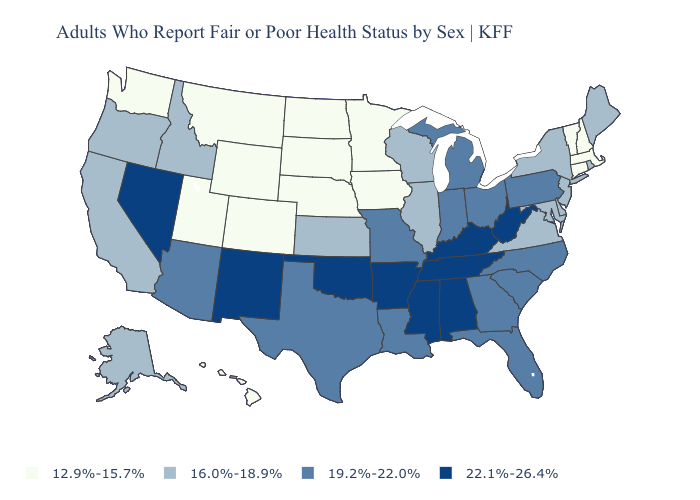Which states have the highest value in the USA?
Answer briefly. Alabama, Arkansas, Kentucky, Mississippi, Nevada, New Mexico, Oklahoma, Tennessee, West Virginia. What is the highest value in the USA?
Concise answer only. 22.1%-26.4%. What is the lowest value in states that border Idaho?
Answer briefly. 12.9%-15.7%. Among the states that border New Jersey , which have the lowest value?
Answer briefly. Delaware, New York. Name the states that have a value in the range 22.1%-26.4%?
Short answer required. Alabama, Arkansas, Kentucky, Mississippi, Nevada, New Mexico, Oklahoma, Tennessee, West Virginia. What is the value of Iowa?
Short answer required. 12.9%-15.7%. Which states hav the highest value in the Northeast?
Write a very short answer. Pennsylvania. Which states have the highest value in the USA?
Short answer required. Alabama, Arkansas, Kentucky, Mississippi, Nevada, New Mexico, Oklahoma, Tennessee, West Virginia. What is the lowest value in states that border Kansas?
Give a very brief answer. 12.9%-15.7%. Name the states that have a value in the range 22.1%-26.4%?
Concise answer only. Alabama, Arkansas, Kentucky, Mississippi, Nevada, New Mexico, Oklahoma, Tennessee, West Virginia. Does South Dakota have the same value as Washington?
Give a very brief answer. Yes. How many symbols are there in the legend?
Concise answer only. 4. Does Ohio have the same value as Texas?
Concise answer only. Yes. What is the lowest value in the USA?
Quick response, please. 12.9%-15.7%. 